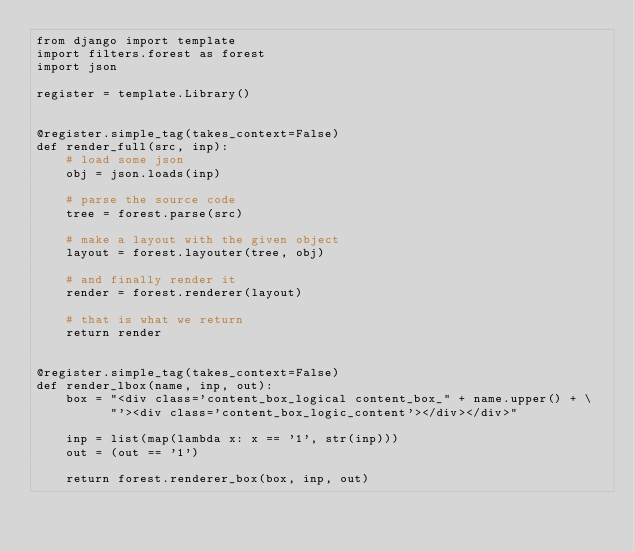Convert code to text. <code><loc_0><loc_0><loc_500><loc_500><_Python_>from django import template
import filters.forest as forest
import json

register = template.Library()


@register.simple_tag(takes_context=False)
def render_full(src, inp):
    # load some json
    obj = json.loads(inp)

    # parse the source code
    tree = forest.parse(src)

    # make a layout with the given object
    layout = forest.layouter(tree, obj)

    # and finally render it
    render = forest.renderer(layout)

    # that is what we return
    return render


@register.simple_tag(takes_context=False)
def render_lbox(name, inp, out):
    box = "<div class='content_box_logical content_box_" + name.upper() + \
          "'><div class='content_box_logic_content'></div></div>"

    inp = list(map(lambda x: x == '1', str(inp)))
    out = (out == '1')

    return forest.renderer_box(box, inp, out)
</code> 